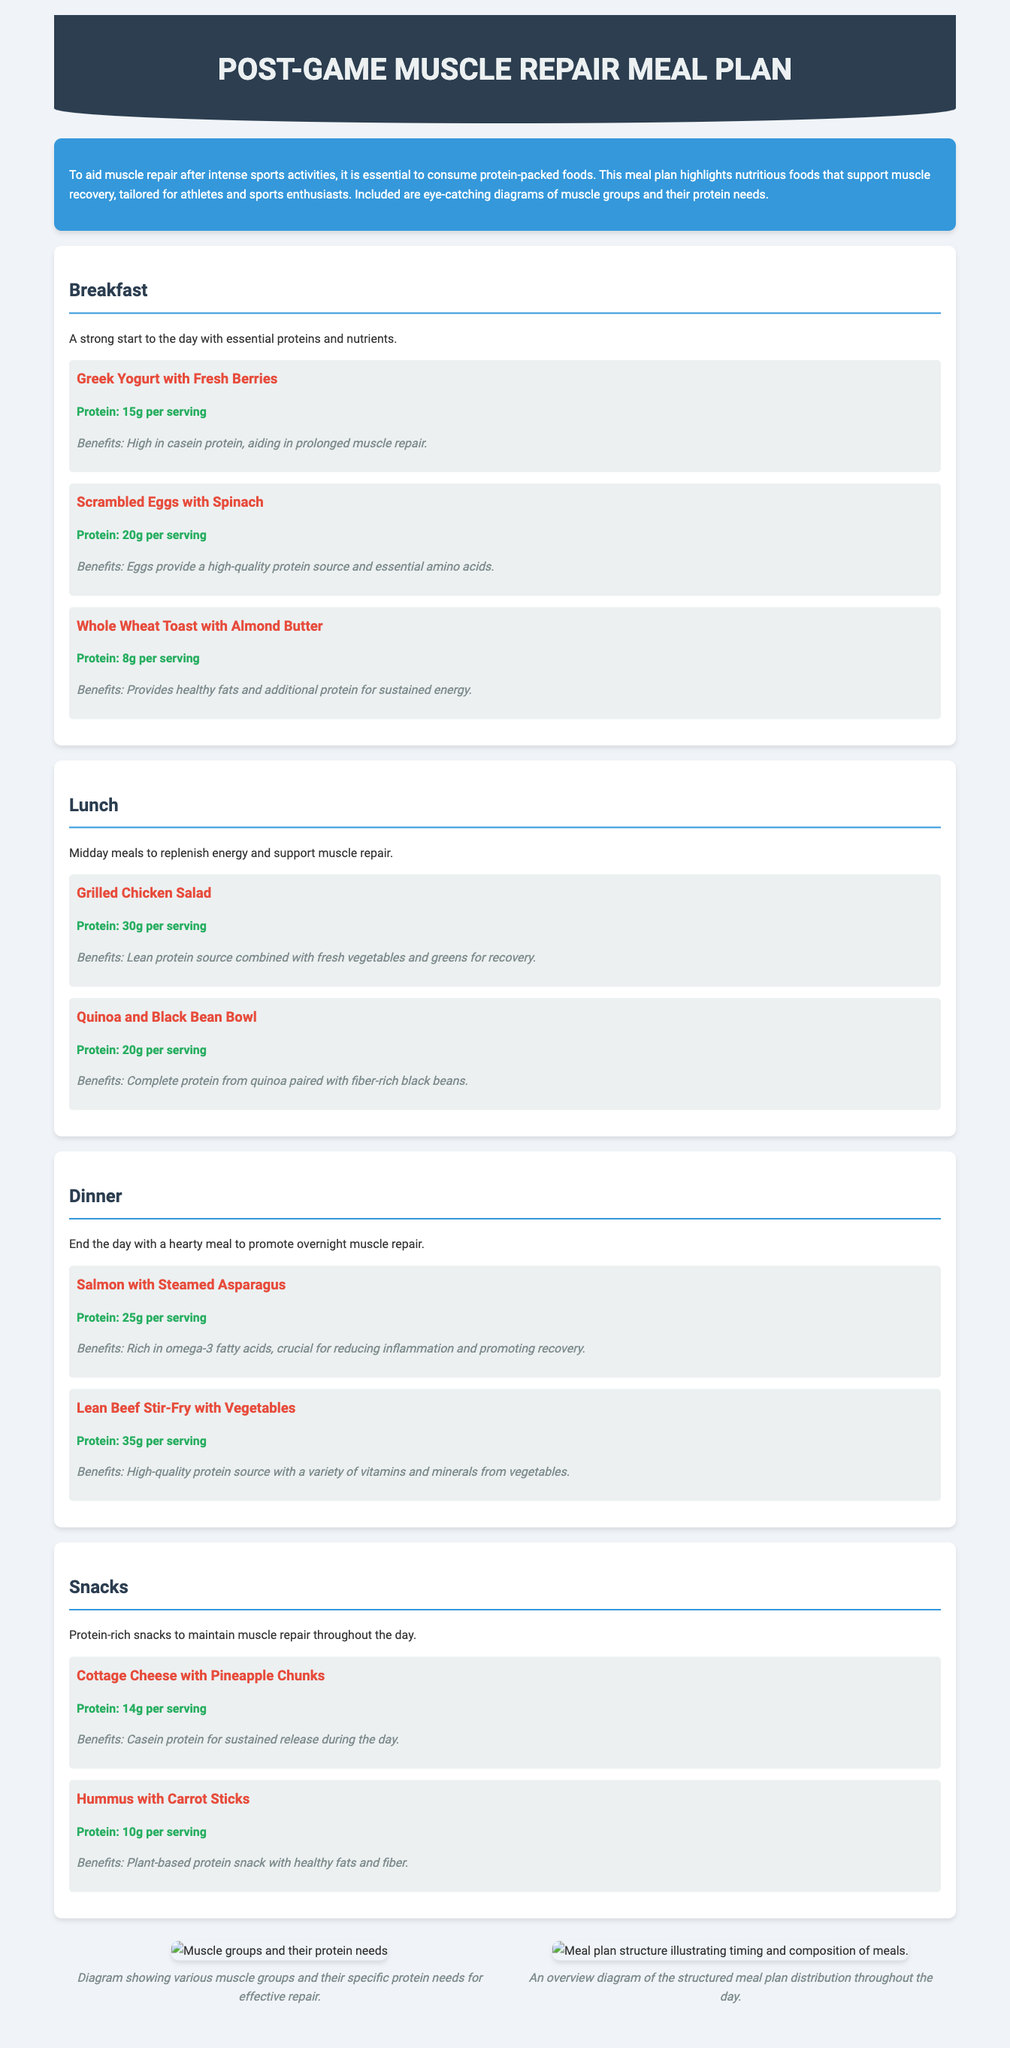What is the main purpose of the meal plan? The introduction section clearly states that the meal plan is designed to aid muscle repair after intense sports activities through protein-packed foods.
Answer: Aid muscle repair How much protein is in scrambled eggs with spinach? The meal section details that scrambled eggs with spinach contain 20g of protein per serving.
Answer: 20g What are the benefits of consuming Greek yogurt with fresh berries? The document specifies that Greek yogurt aids in prolonged muscle repair due to its high casein protein content.
Answer: Prolonged muscle repair What protein source is provided by the quinoa and black bean bowl? The benefits section notes that it offers complete protein from quinoa along with fiber from black beans.
Answer: Complete protein How many servings of protein are in salmon with steamed asparagus? The meal details indicate that salmon with steamed asparagus provides 25g of protein per serving.
Answer: 25g Which meal includes a high-quality protein source with essential amino acids? The scrambled eggs with spinach is highlighted as providing a high-quality protein source along with essential amino acids.
Answer: Scrambled eggs with spinach What type of protein can be found in cottage cheese? The benefits indicate that cottage cheese contains casein protein for sustained release.
Answer: Casein protein Which meal is designed for a hearty dinner to promote overnight muscle repair? The document states that the salmon with steamed asparagus is aimed to promote overnight muscle repair.
Answer: Salmon with steamed asparagus 